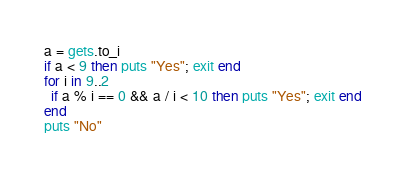<code> <loc_0><loc_0><loc_500><loc_500><_Ruby_>a = gets.to_i
if a < 9 then puts "Yes"; exit end
for i in 9..2
  if a % i == 0 && a / i < 10 then puts "Yes"; exit end
end
puts "No"</code> 